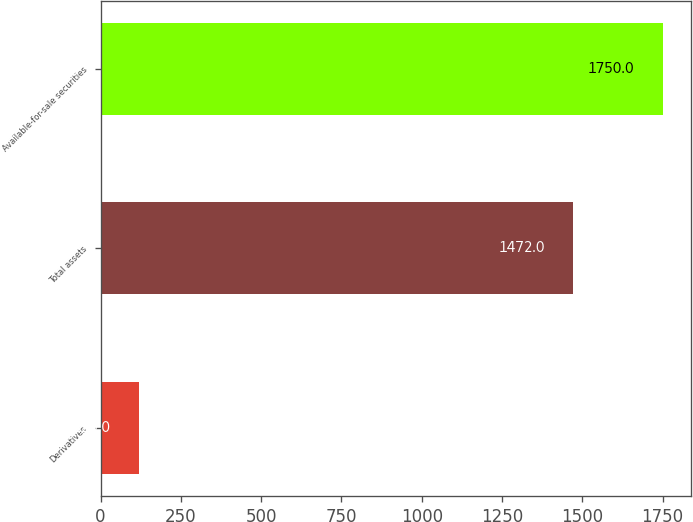Convert chart to OTSL. <chart><loc_0><loc_0><loc_500><loc_500><bar_chart><fcel>Derivatives<fcel>Total assets<fcel>Available-for-sale securities<nl><fcel>120<fcel>1472<fcel>1750<nl></chart> 